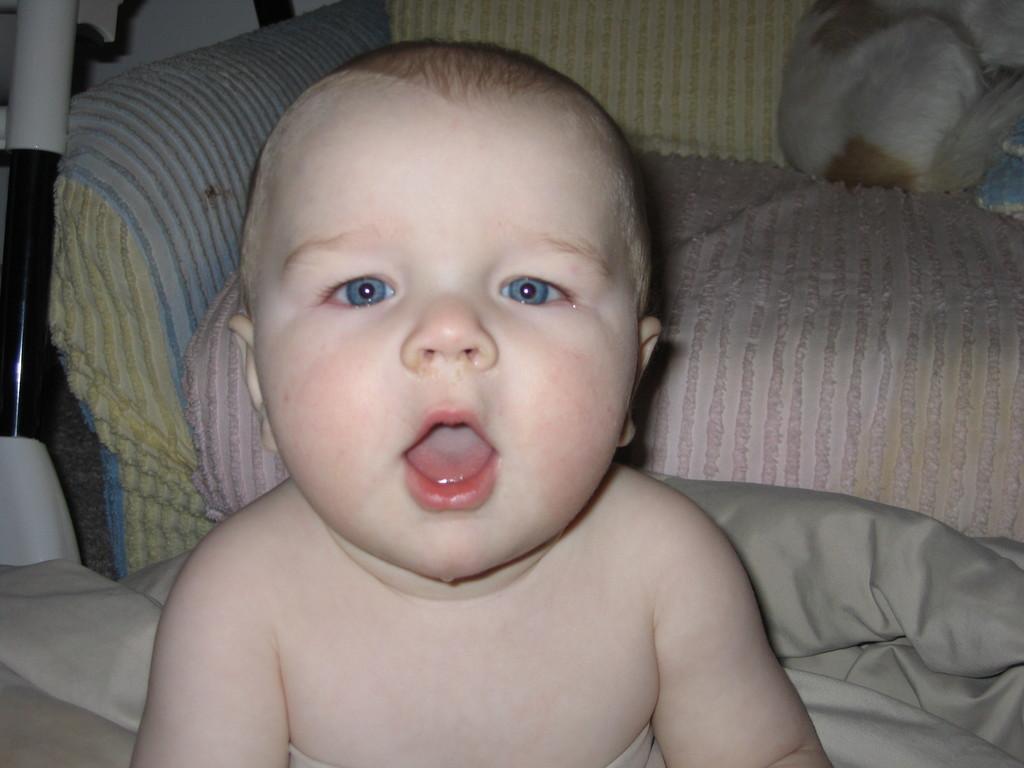Could you give a brief overview of what you see in this image? In this picture I can see a baby. I can see a couch and some other objects. 